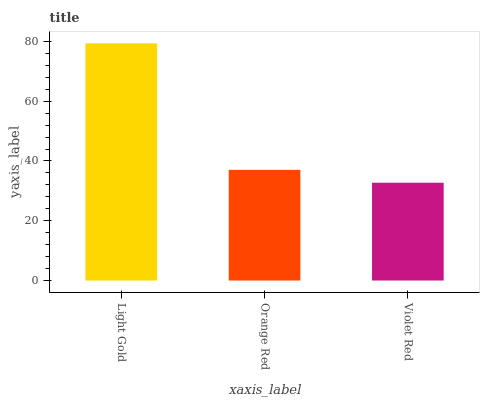Is Orange Red the minimum?
Answer yes or no. No. Is Orange Red the maximum?
Answer yes or no. No. Is Light Gold greater than Orange Red?
Answer yes or no. Yes. Is Orange Red less than Light Gold?
Answer yes or no. Yes. Is Orange Red greater than Light Gold?
Answer yes or no. No. Is Light Gold less than Orange Red?
Answer yes or no. No. Is Orange Red the high median?
Answer yes or no. Yes. Is Orange Red the low median?
Answer yes or no. Yes. Is Light Gold the high median?
Answer yes or no. No. Is Violet Red the low median?
Answer yes or no. No. 